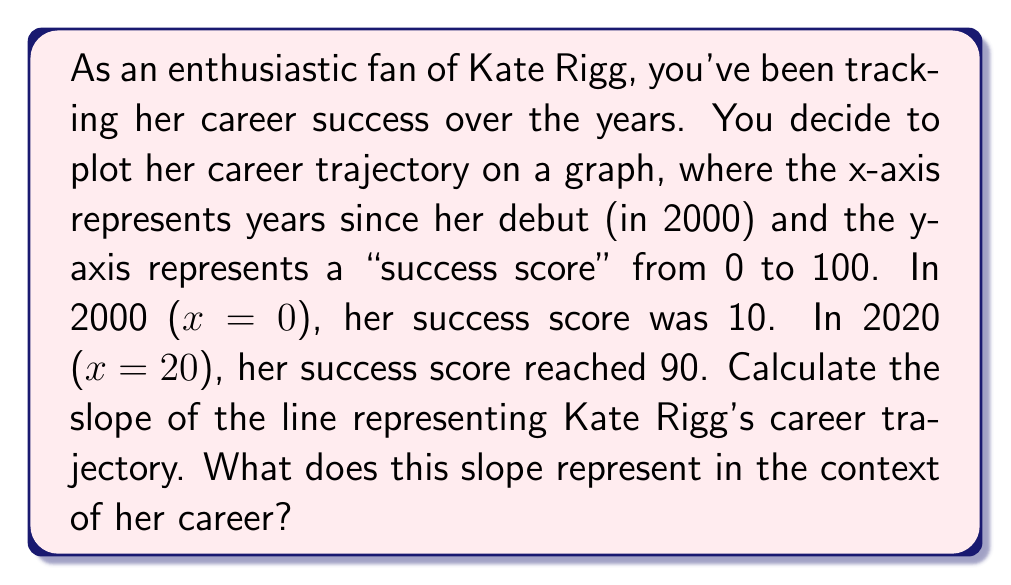Solve this math problem. To calculate the slope of the line representing Kate Rigg's career trajectory, we'll use the slope formula:

$$ m = \frac{y_2 - y_1}{x_2 - x_1} $$

Where:
$(x_1, y_1)$ is the point representing her career at the start (2000)
$(x_2, y_2)$ is the point representing her career in 2020

Given:
$(x_1, y_1) = (0, 10)$
$(x_2, y_2) = (20, 90)$

Plugging these values into the slope formula:

$$ m = \frac{90 - 10}{20 - 0} = \frac{80}{20} = 4 $$

The slope of 4 represents the rate at which Kate Rigg's success score increased per year. It indicates that, on average, her success score increased by 4 points each year between 2000 and 2020.

This positive slope reflects a steadily rising career trajectory, showing consistent growth and increasing success over time. As an enthusiastic fan, you can interpret this as Kate Rigg's continuous improvement and growing recognition in her field.
Answer: The slope of Kate Rigg's career trajectory line is 4. This means her success score increased by an average of 4 points per year from 2000 to 2020, indicating a steady and positive career growth. 